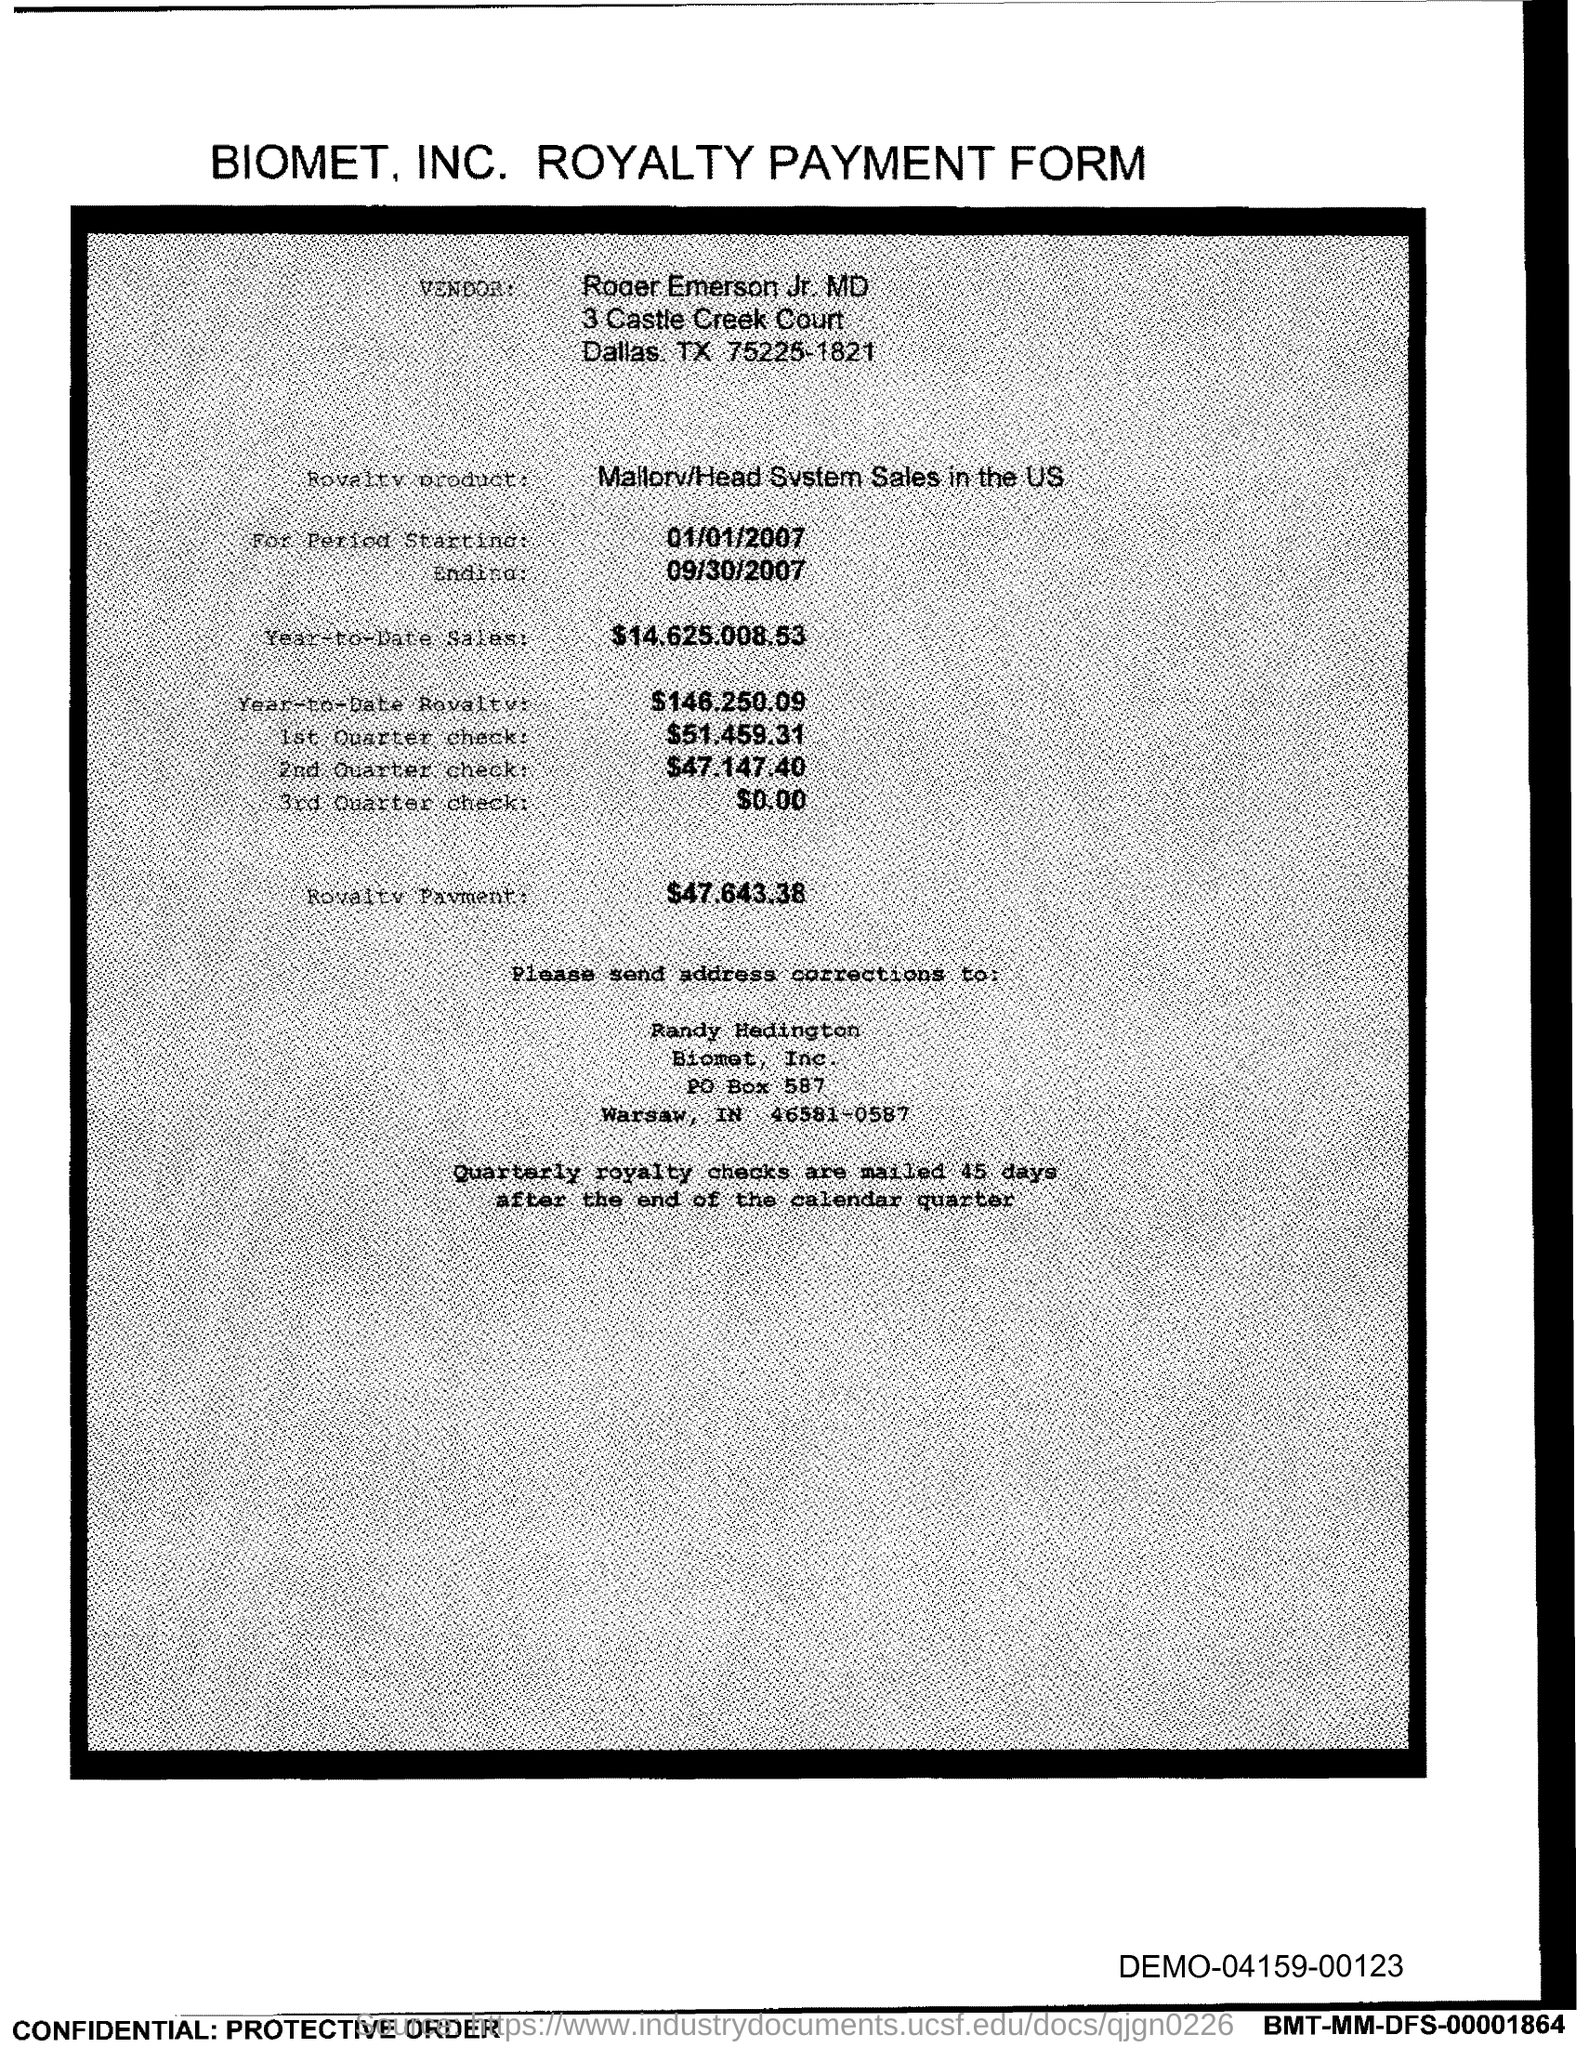Specify some key components in this picture. The end date of the royalty period is September 30, 2007. The royalty payment for the product mentioned in the form is $47,643.38. The start date of the royalty period is September 30, 2007. The year-to-date sales of the royalty product are 14,625,008.53... The vendor mentioned in the form is Roger Emerson Jr. 